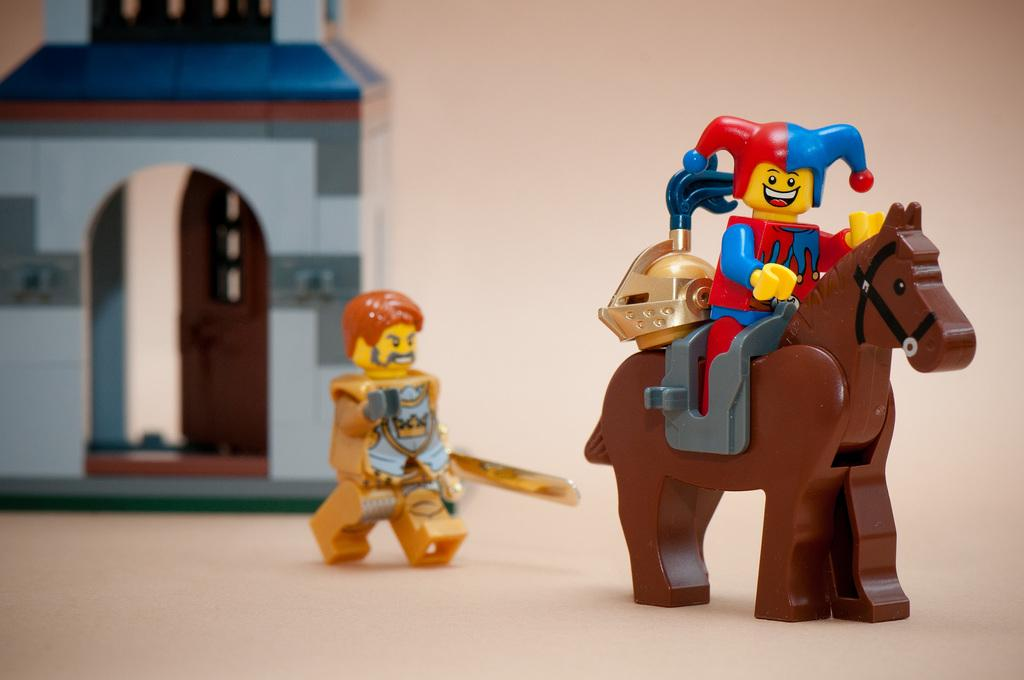What is the main subject of the image? The main subject of the image is a toy sitting on a horse toy. Are there any other toys visible in the image? Yes, there is another toy behind the first toy. Can you describe the background of the image? There is an unspecified object in the background. What type of musical instrument is being played by the toy in the image? There is no musical instrument present in the image, and the toy is not depicted as playing any instrument. 